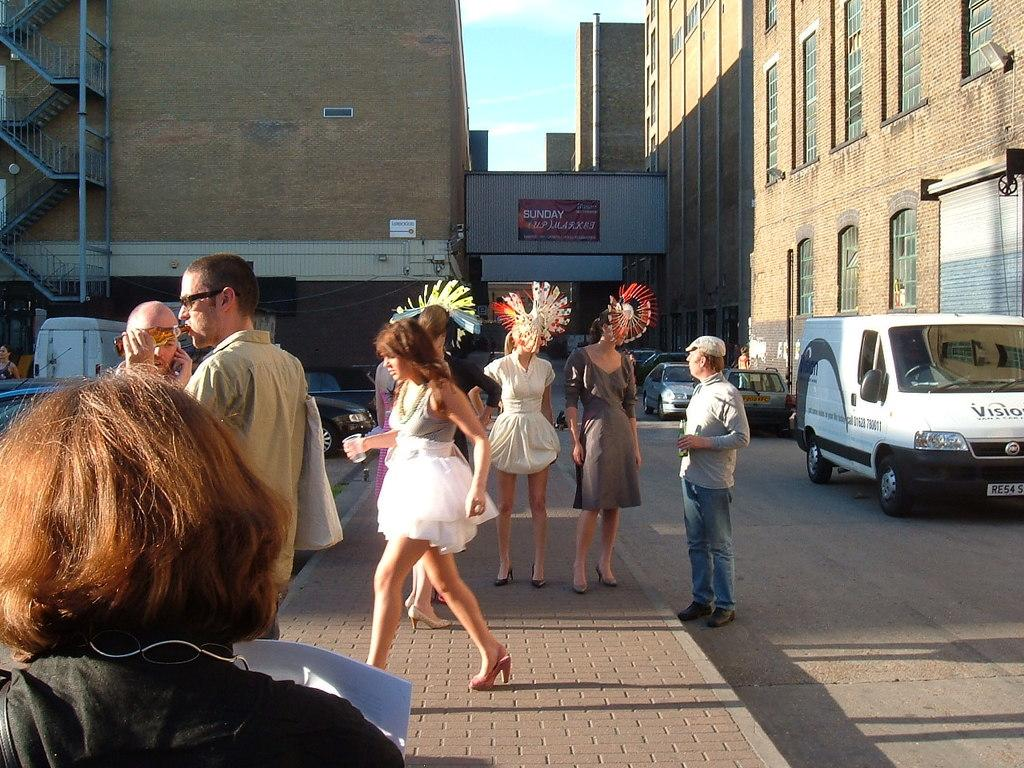What can be seen on the road in the image? There are people and vehicles on the road in the image. What is visible in the background of the image? There are buildings in the background of the image. What type of ear is visible on the road in the image? There is no ear present in the image; it features people and vehicles on the road. What brand of soda can be seen being consumed by the people in the image? There is no soda visible in the image, nor is there any indication that the people are consuming any beverages. 